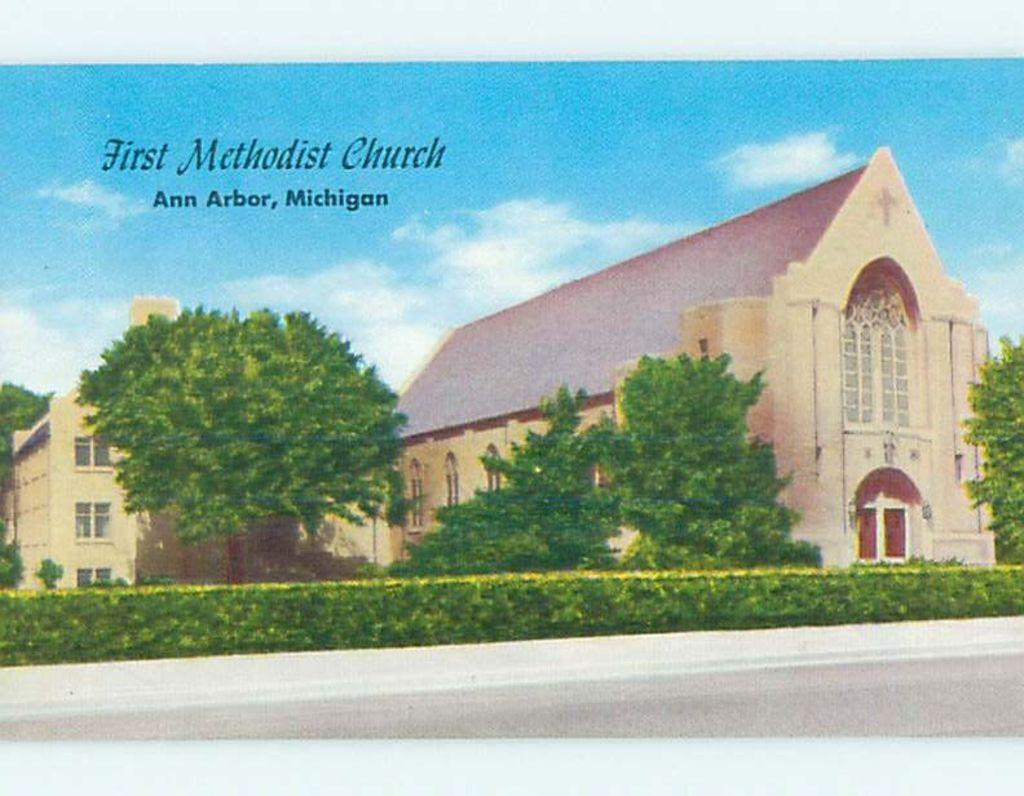What is the main subject of the poster in the image? The poster contains images of houses, trees, and plants. What else can be seen on the poster besides the images? There is text on the poster. What is visible in the background of the image? The sky is visible in the background of the image. What type of instrument is being played in the image? There is no instrument present in the image. What health-related information is being discussed in the image? There is no discussion about health-related information in the image. 